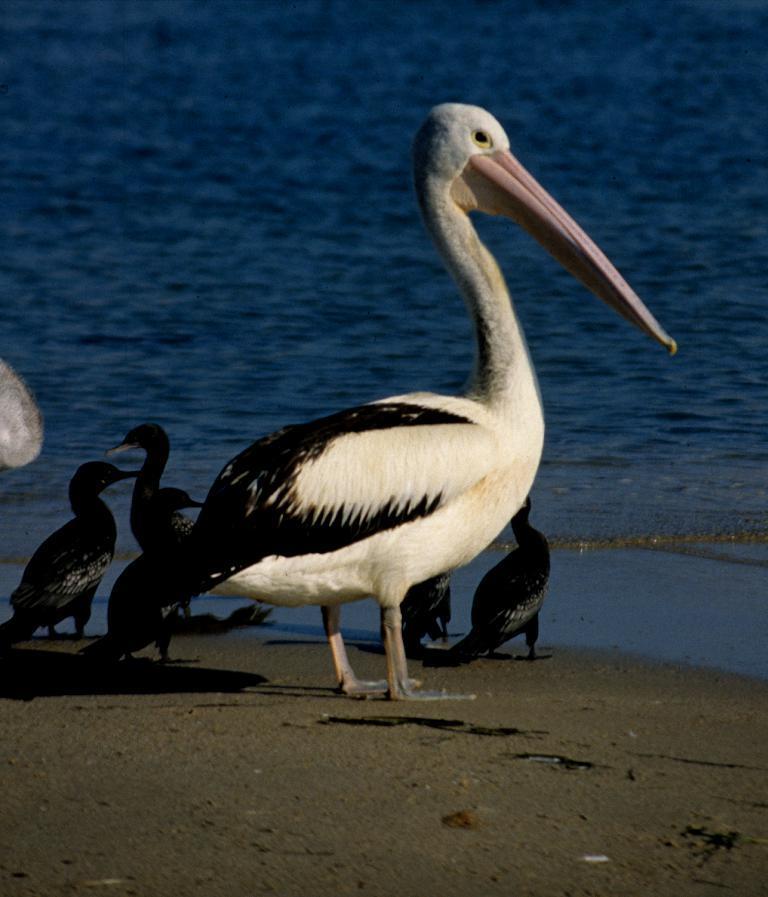Could you give a brief overview of what you see in this image? In the center of the image there are birds. In the background of the image there is water. At the bottom of the image there is sand 